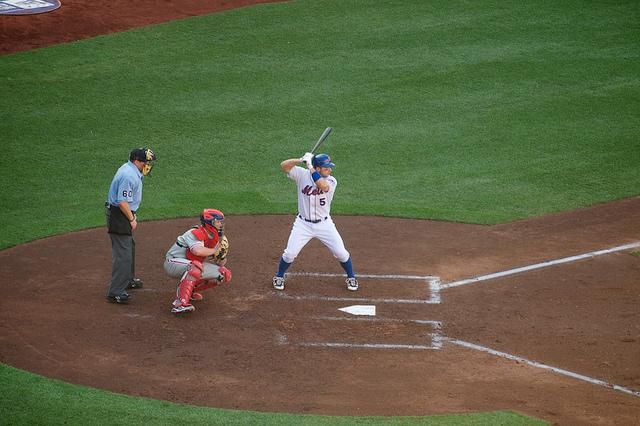Is the man in motion?
Quick response, please. No. Could a spectator have taken this shot?
Give a very brief answer. Yes. What is the color of the catcher's hat?
Write a very short answer. Red. Yes it might a be spectator?
Give a very brief answer. No. Is the man swinging the bat?
Short answer required. No. What color is the umpire wearing?
Keep it brief. Blue and gray. What number is on the batter's jersey?
Keep it brief. 5. 